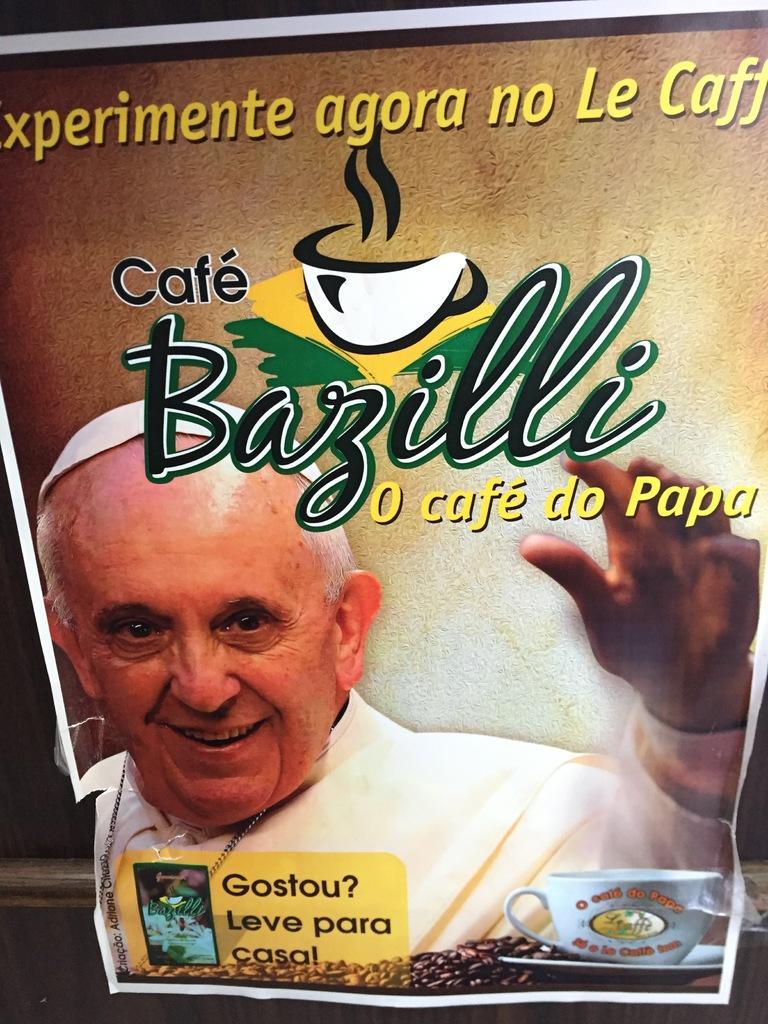Describe this image in one or two sentences. In this picture there is a poster on the rod. In the poster there is a picture of a person smiling and there is cup, saucer and there are coffee beans and there is a text. 